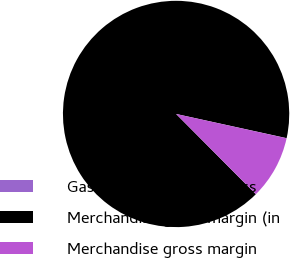Convert chart to OTSL. <chart><loc_0><loc_0><loc_500><loc_500><pie_chart><fcel>Gasoline & distillate gross<fcel>Merchandise gross margin (in<fcel>Merchandise gross margin<nl><fcel>0.02%<fcel>90.88%<fcel>9.1%<nl></chart> 